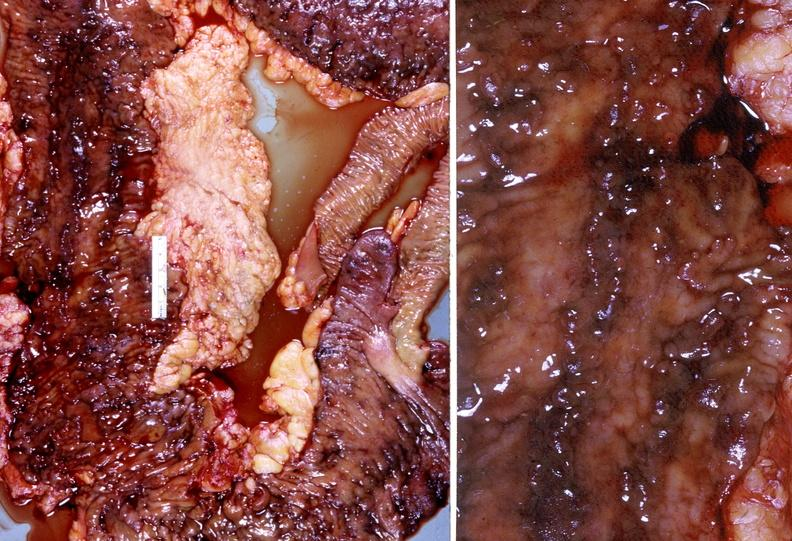what does this image show?
Answer the question using a single word or phrase. Colon 